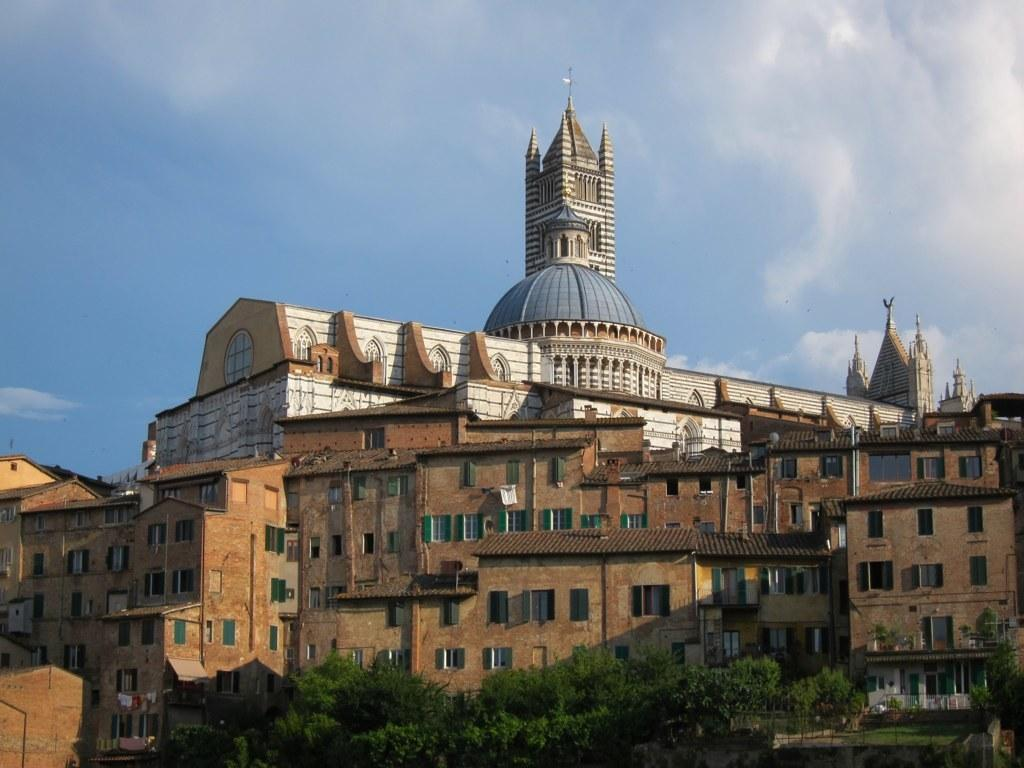What is the color of the building in the front of the image? The building in the front of the image is brown. Can you describe the other building in the image? There is a white building with a grey dome and tower in the image. What type of vegetation can be seen in the image? Trees are visible in the front bottom side of the image. What type of advertisement can be seen on the brown building in the image? There is no advertisement visible on the brown building in the image. 